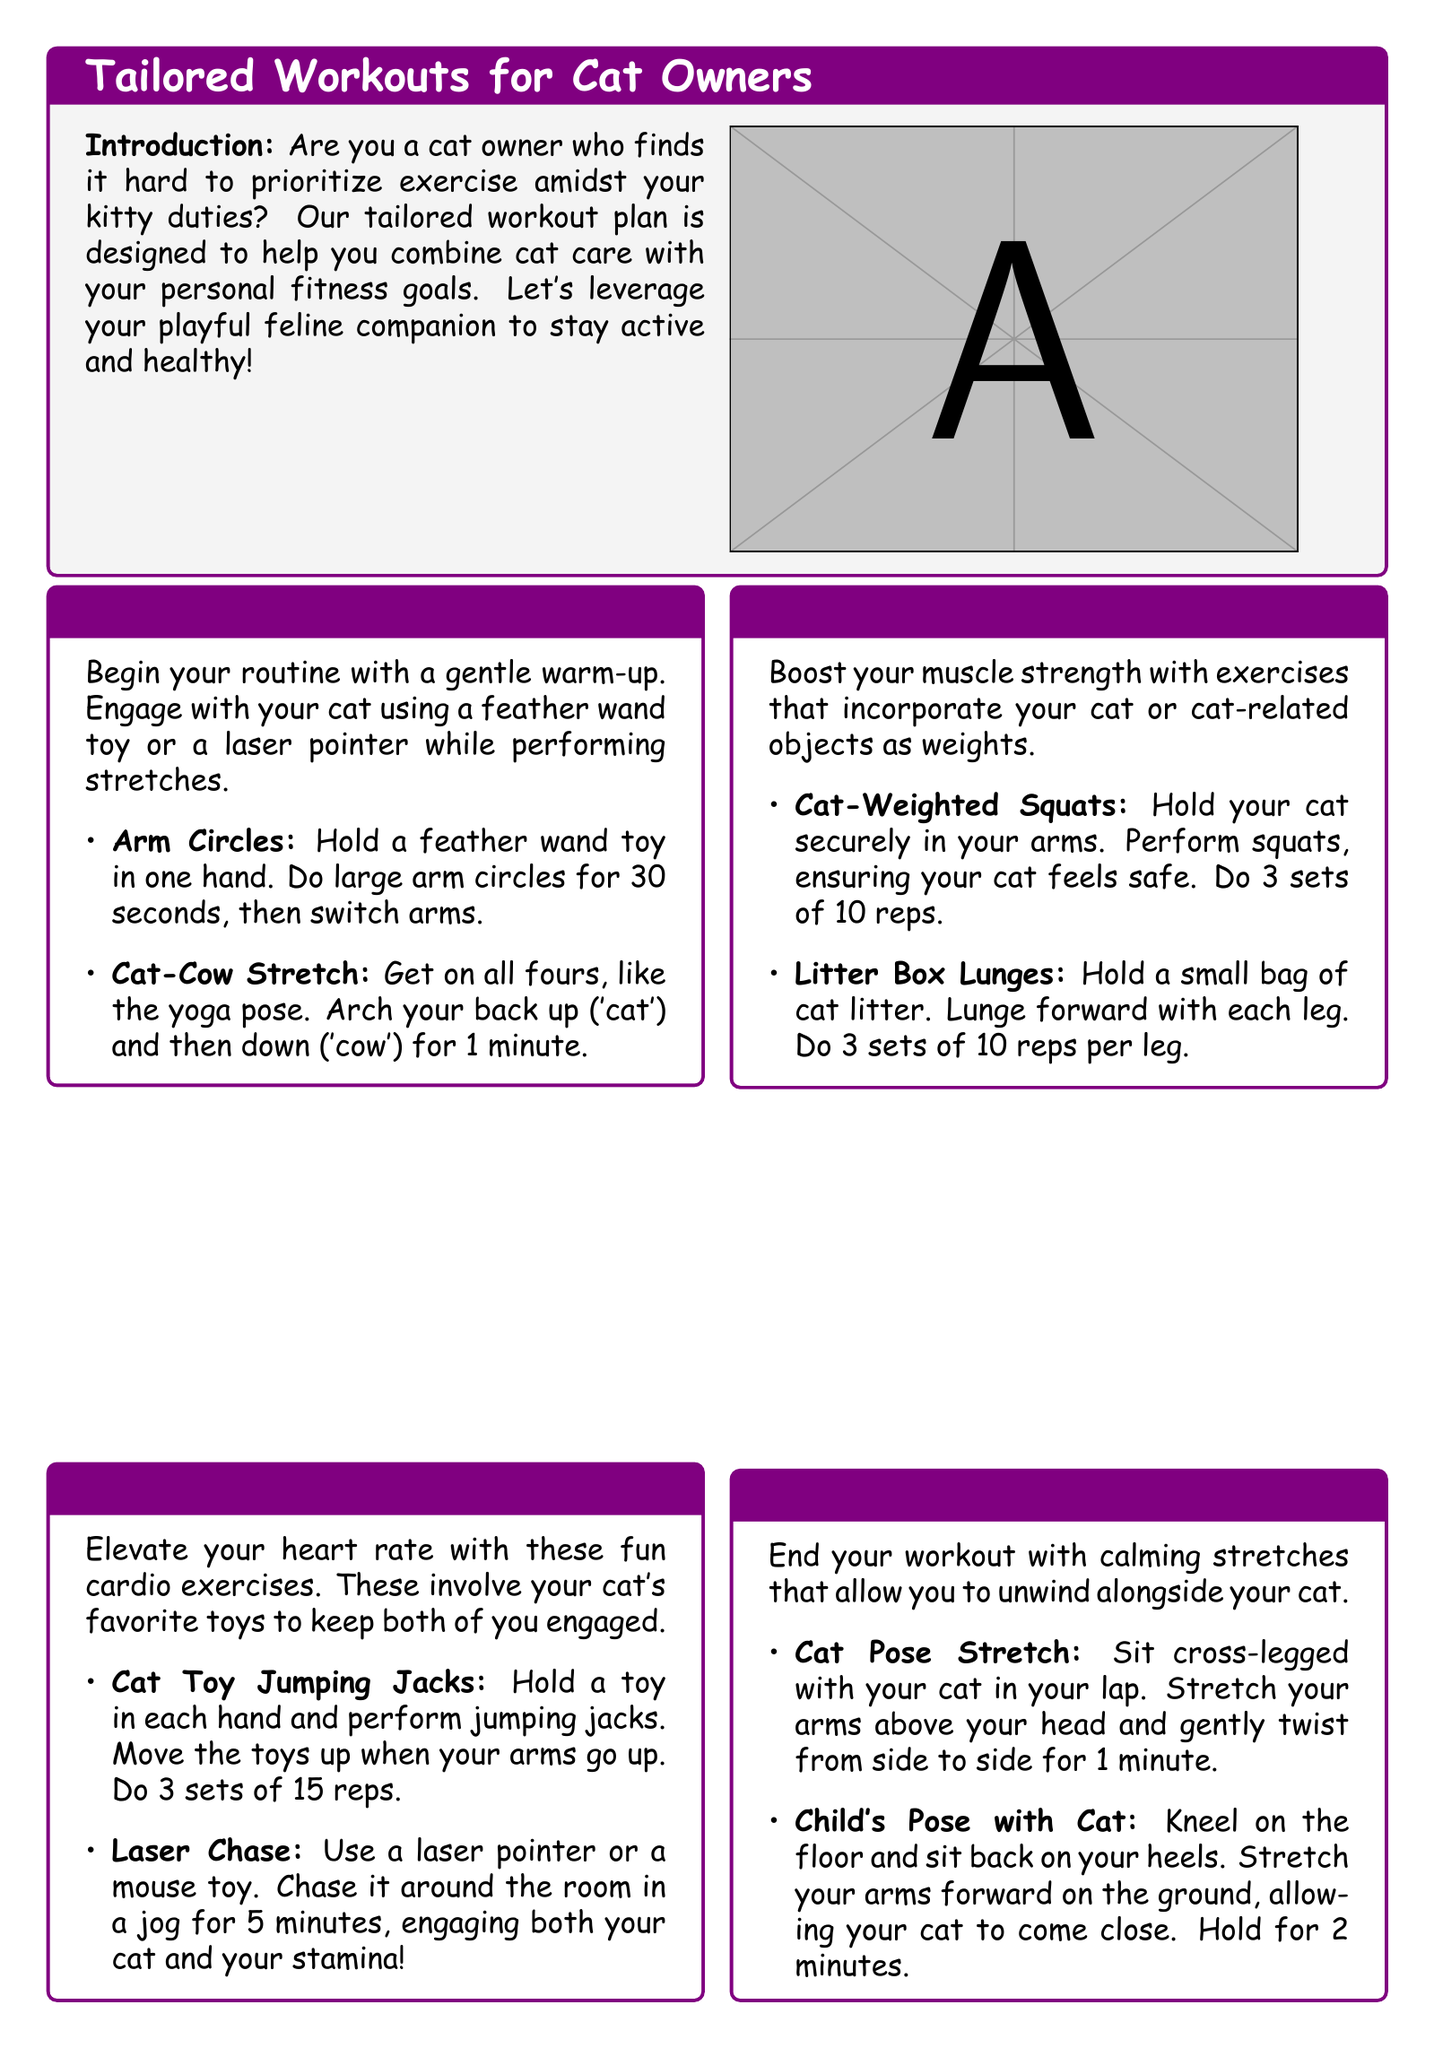What is the title of the document? The title is found at the top of the document in the highlighted box.
Answer: Tailored Workouts for Cat Owners What exercise uses a feather wand toy? This exercise is specifically detailed under the warm-up section.
Answer: Arm Circles How long should the Laser Chase activity last? The duration of this activity is mentioned in the cardio section.
Answer: 5 minutes What is the recommended number of reps for Cat-Weighted Squats? This information can be found in the strength training section of the document.
Answer: 10 reps What is the color of the title boxes in the document? This describes the color scheme used for different sections of the document.
Answer: Cat purple Which pose involves kneeling on the floor? This is part of the cool down section addressing a specific stretching pose.
Answer: Child's Pose How many sets of Cat Toy Jumping Jacks are recommended? The number of sets is specifically listed in the cardio section.
Answer: 3 sets What is the purpose of the document? The main goal of the document is outlined in the introduction.
Answer: Combine cat care with personal fitness goals 